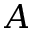<formula> <loc_0><loc_0><loc_500><loc_500>A</formula> 